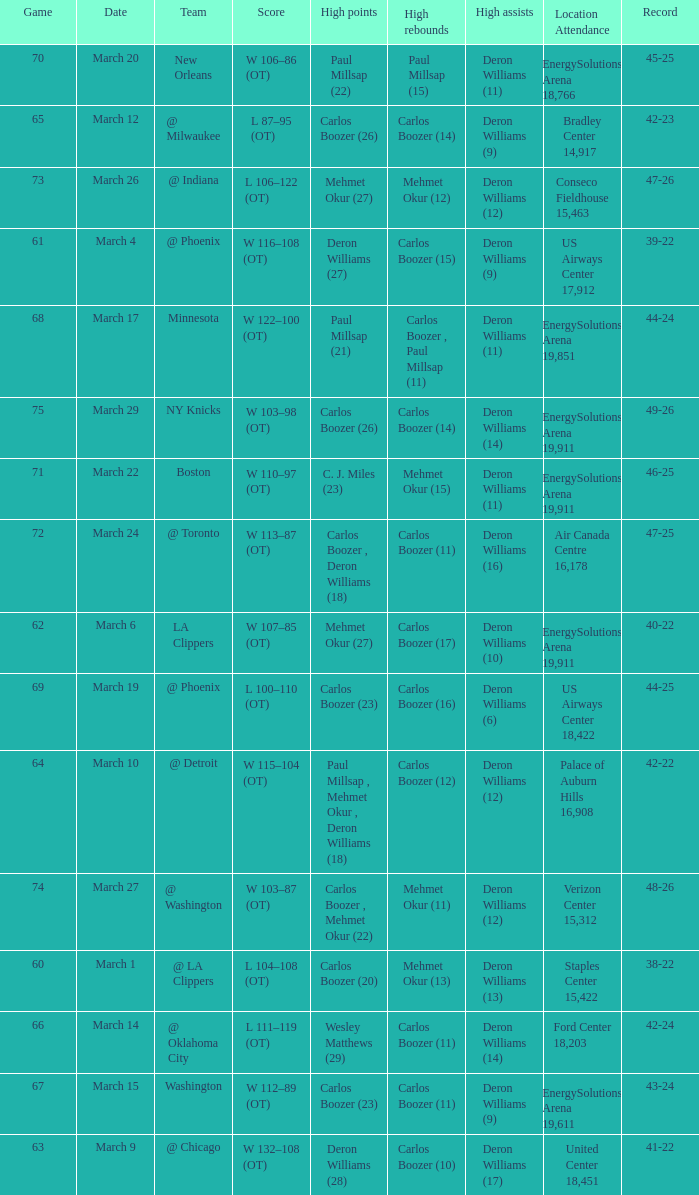Where was the March 24 game played? Air Canada Centre 16,178. 